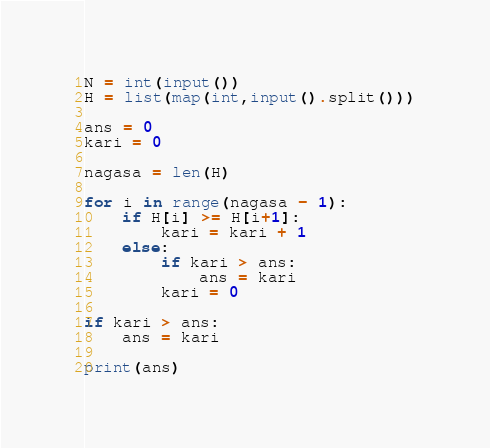<code> <loc_0><loc_0><loc_500><loc_500><_Python_>N = int(input())
H = list(map(int,input().split()))

ans = 0
kari = 0

nagasa = len(H)

for i in range(nagasa - 1):
    if H[i] >= H[i+1]:
        kari = kari + 1
    else:
        if kari > ans:
            ans = kari
        kari = 0

if kari > ans:
    ans = kari

print(ans)</code> 